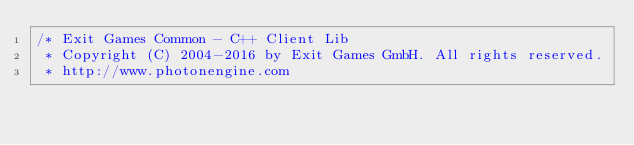Convert code to text. <code><loc_0><loc_0><loc_500><loc_500><_C_>/* Exit Games Common - C++ Client Lib
 * Copyright (C) 2004-2016 by Exit Games GmbH. All rights reserved.
 * http://www.photonengine.com</code> 